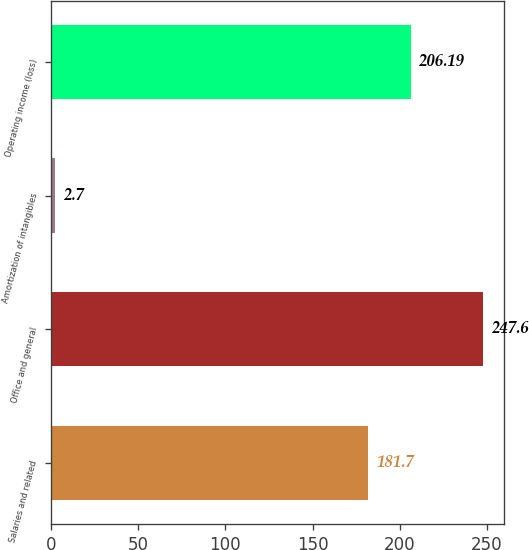<chart> <loc_0><loc_0><loc_500><loc_500><bar_chart><fcel>Salaries and related<fcel>Office and general<fcel>Amortization of intangibles<fcel>Operating income (loss)<nl><fcel>181.7<fcel>247.6<fcel>2.7<fcel>206.19<nl></chart> 